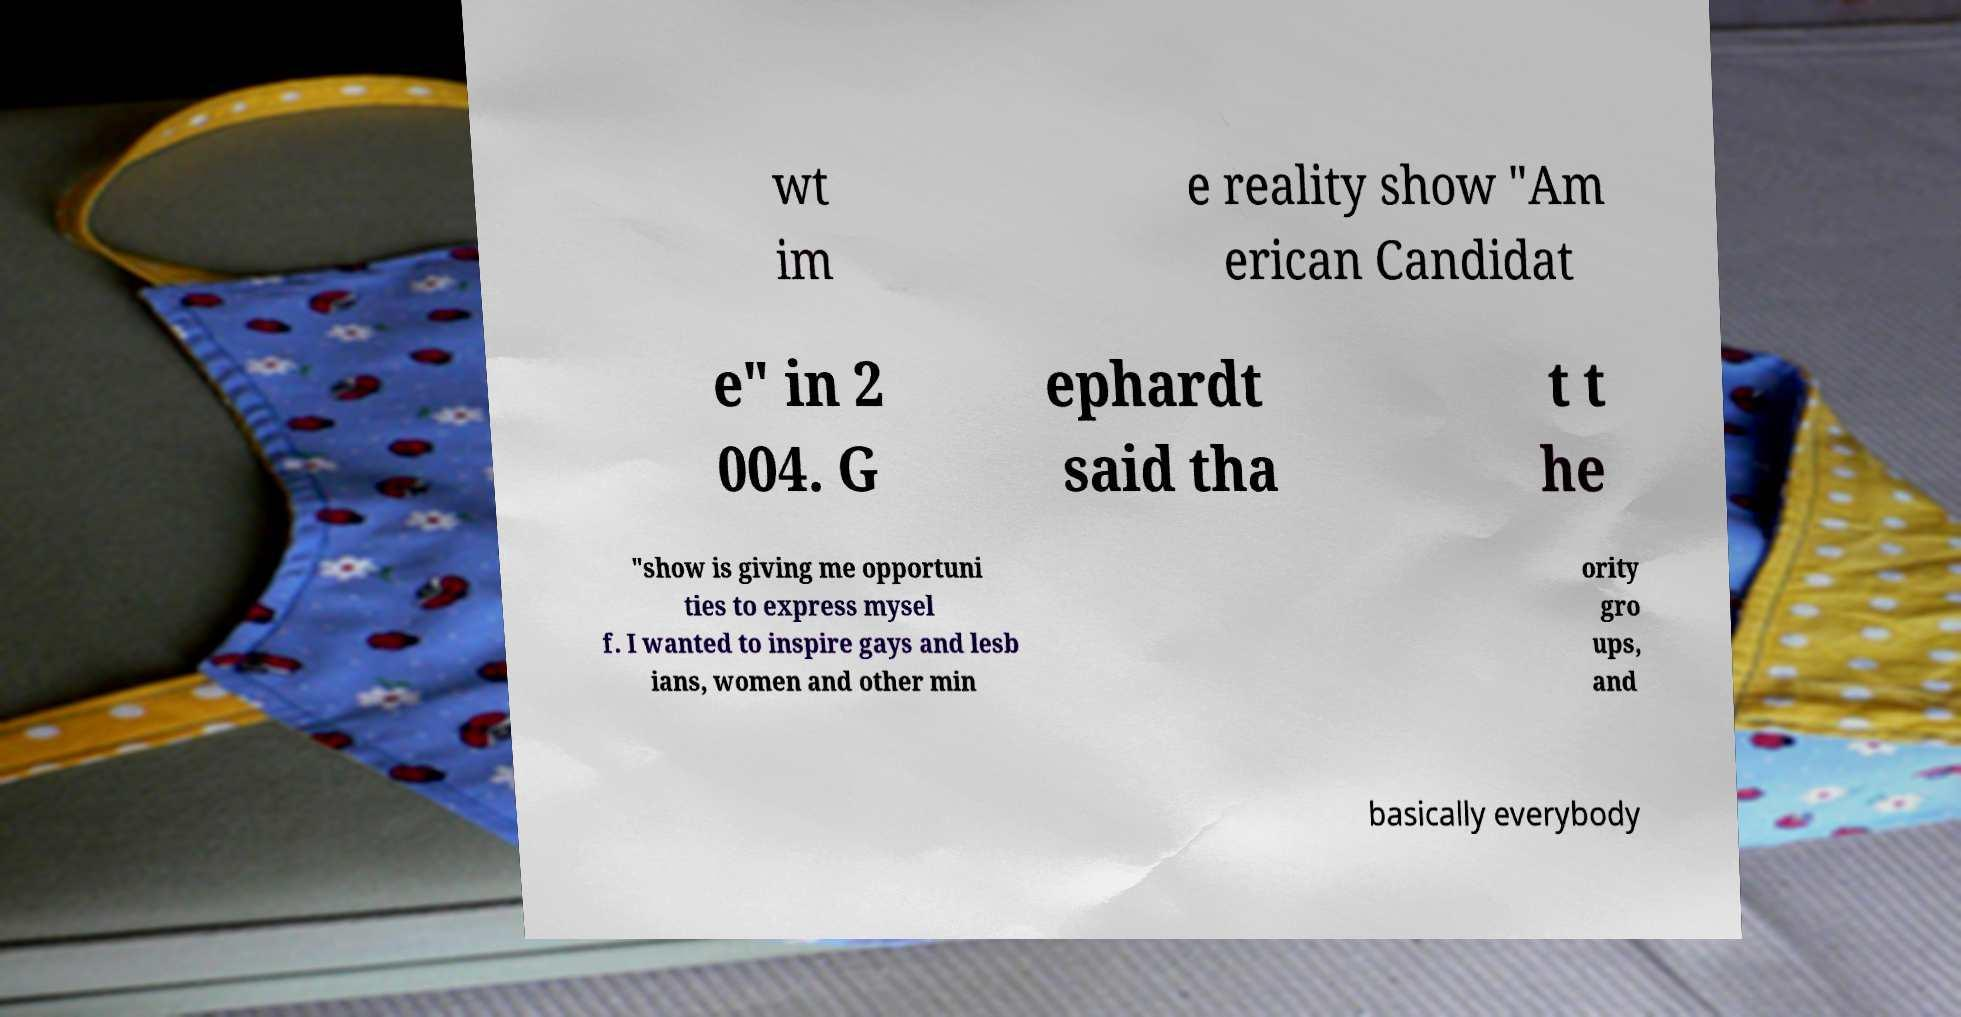Can you read and provide the text displayed in the image?This photo seems to have some interesting text. Can you extract and type it out for me? wt im e reality show "Am erican Candidat e" in 2 004. G ephardt said tha t t he "show is giving me opportuni ties to express mysel f. I wanted to inspire gays and lesb ians, women and other min ority gro ups, and basically everybody 